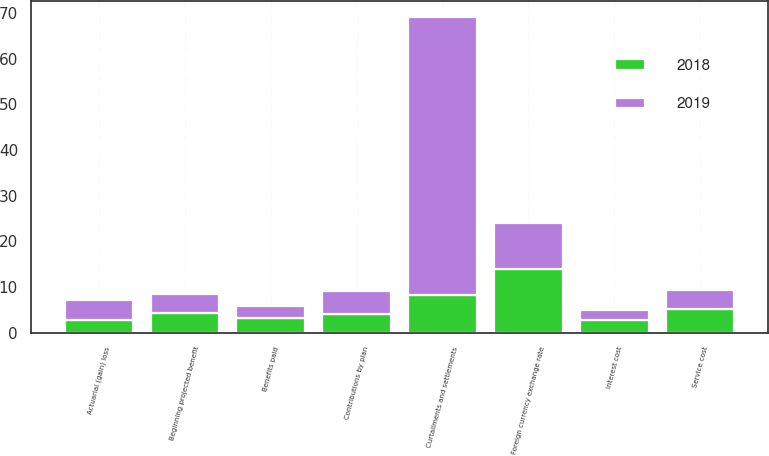Convert chart. <chart><loc_0><loc_0><loc_500><loc_500><stacked_bar_chart><ecel><fcel>Beginning projected benefit<fcel>Service cost<fcel>Interest cost<fcel>Actuarial (gain) loss<fcel>Benefits paid<fcel>Foreign currency exchange rate<fcel>Curtailments and settlements<fcel>Contributions by plan<nl><fcel>2019<fcel>4.2<fcel>4.1<fcel>2.3<fcel>4.3<fcel>2.6<fcel>10<fcel>61<fcel>5<nl><fcel>2018<fcel>4.2<fcel>5.2<fcel>2.7<fcel>2.8<fcel>3.3<fcel>13.9<fcel>8.2<fcel>4<nl></chart> 